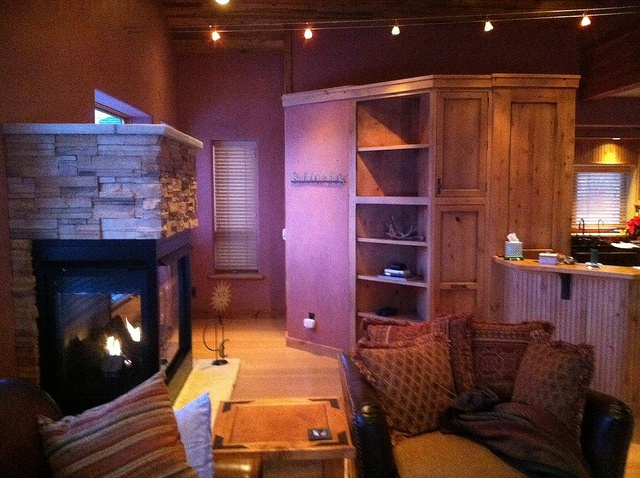Describe the objects in this image and their specific colors. I can see chair in black, maroon, and brown tones, couch in black, maroon, gray, and brown tones, tv in black, navy, maroon, and ivory tones, dining table in black, red, maroon, brown, and orange tones, and book in black, gray, navy, and darkblue tones in this image. 